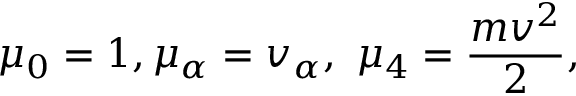Convert formula to latex. <formula><loc_0><loc_0><loc_500><loc_500>\mu _ { 0 } = 1 , \mu _ { \alpha } = v _ { \alpha } , \ \mu _ { 4 } = { \frac { m v ^ { 2 } } { 2 } } ,</formula> 